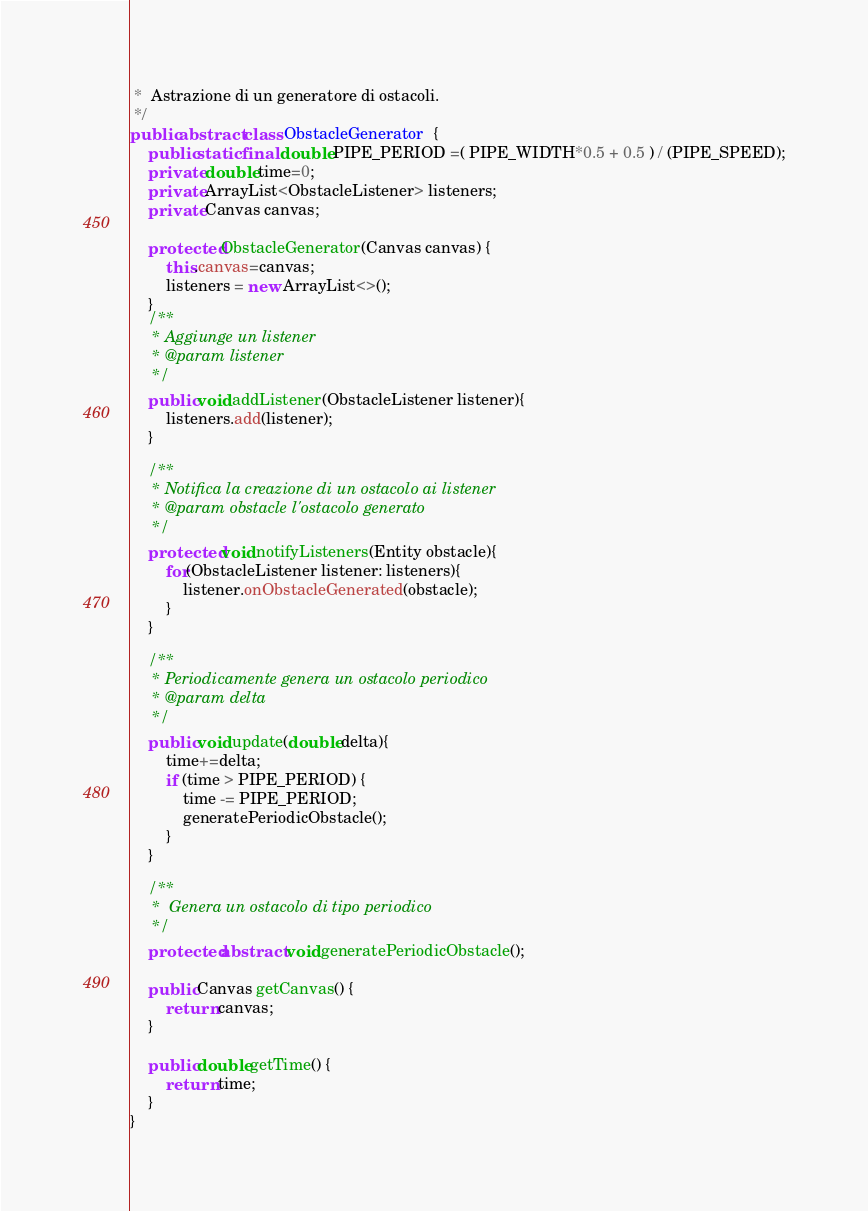Convert code to text. <code><loc_0><loc_0><loc_500><loc_500><_Java_> *  Astrazione di un generatore di ostacoli.
 */
public abstract class ObstacleGenerator  {
    public static final double PIPE_PERIOD =( PIPE_WIDTH*0.5 + 0.5 ) / (PIPE_SPEED);
    private double time=0;
    private ArrayList<ObstacleListener> listeners;
    private Canvas canvas;

    protected ObstacleGenerator(Canvas canvas) {
        this.canvas=canvas;
        listeners = new ArrayList<>();
    }
    /**
     * Aggiunge un listener
     * @param listener
     */
    public void addListener(ObstacleListener listener){
        listeners.add(listener);
    }

    /**
     * Notifica la creazione di un ostacolo ai listener
     * @param obstacle l'ostacolo generato
     */
    protected void notifyListeners(Entity obstacle){
        for(ObstacleListener listener: listeners){
            listener.onObstacleGenerated(obstacle);
        }
    }

    /**
     * Periodicamente genera un ostacolo periodico
     * @param delta
     */
    public void update(double delta){
        time+=delta;
        if (time > PIPE_PERIOD) {
            time -= PIPE_PERIOD;
            generatePeriodicObstacle();
        }
    }

    /**
     *  Genera un ostacolo di tipo periodico
     */
    protected abstract void generatePeriodicObstacle();

    public Canvas getCanvas() {
        return canvas;
    }

    public double getTime() {
        return time;
    }
}
</code> 